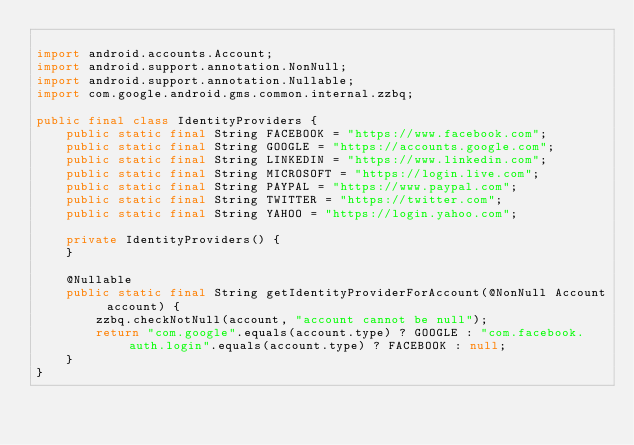Convert code to text. <code><loc_0><loc_0><loc_500><loc_500><_Java_>
import android.accounts.Account;
import android.support.annotation.NonNull;
import android.support.annotation.Nullable;
import com.google.android.gms.common.internal.zzbq;

public final class IdentityProviders {
    public static final String FACEBOOK = "https://www.facebook.com";
    public static final String GOOGLE = "https://accounts.google.com";
    public static final String LINKEDIN = "https://www.linkedin.com";
    public static final String MICROSOFT = "https://login.live.com";
    public static final String PAYPAL = "https://www.paypal.com";
    public static final String TWITTER = "https://twitter.com";
    public static final String YAHOO = "https://login.yahoo.com";

    private IdentityProviders() {
    }

    @Nullable
    public static final String getIdentityProviderForAccount(@NonNull Account account) {
        zzbq.checkNotNull(account, "account cannot be null");
        return "com.google".equals(account.type) ? GOOGLE : "com.facebook.auth.login".equals(account.type) ? FACEBOOK : null;
    }
}
</code> 